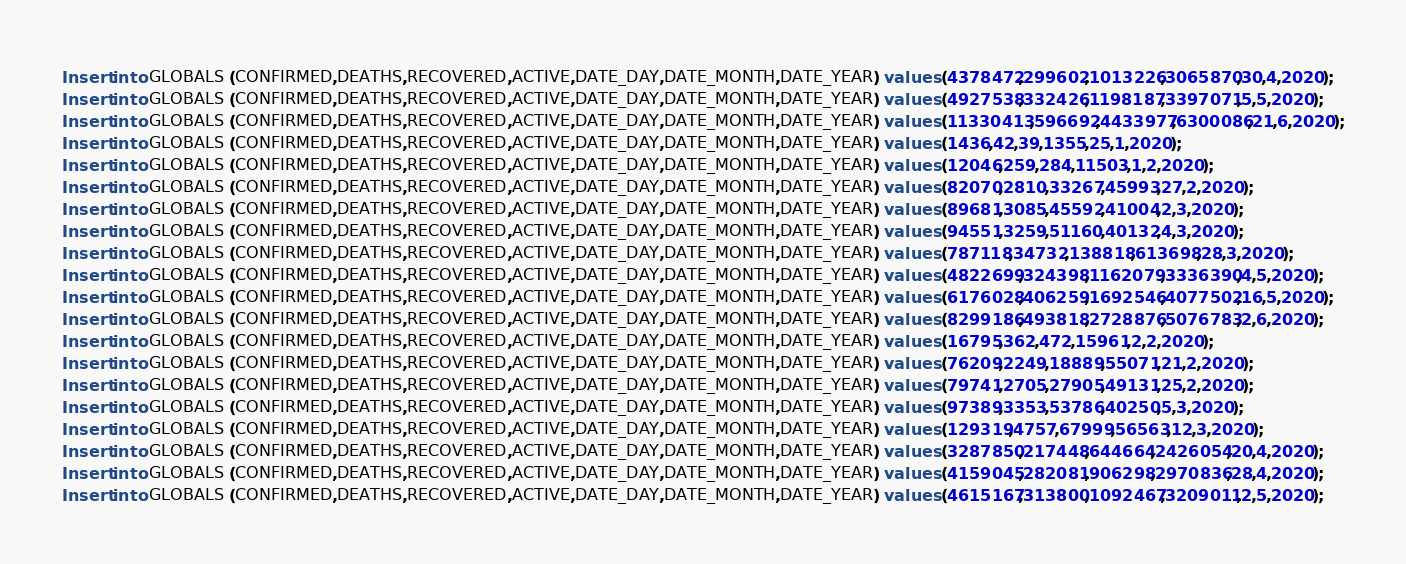Convert code to text. <code><loc_0><loc_0><loc_500><loc_500><_SQL_>Insert into GLOBALS (CONFIRMED,DEATHS,RECOVERED,ACTIVE,DATE_DAY,DATE_MONTH,DATE_YEAR) values (4378472,299602,1013226,3065870,30,4,2020);
Insert into GLOBALS (CONFIRMED,DEATHS,RECOVERED,ACTIVE,DATE_DAY,DATE_MONTH,DATE_YEAR) values (4927538,332426,1198187,3397071,5,5,2020);
Insert into GLOBALS (CONFIRMED,DEATHS,RECOVERED,ACTIVE,DATE_DAY,DATE_MONTH,DATE_YEAR) values (11330413,596692,4433977,6300086,21,6,2020);
Insert into GLOBALS (CONFIRMED,DEATHS,RECOVERED,ACTIVE,DATE_DAY,DATE_MONTH,DATE_YEAR) values (1436,42,39,1355,25,1,2020);
Insert into GLOBALS (CONFIRMED,DEATHS,RECOVERED,ACTIVE,DATE_DAY,DATE_MONTH,DATE_YEAR) values (12046,259,284,11503,1,2,2020);
Insert into GLOBALS (CONFIRMED,DEATHS,RECOVERED,ACTIVE,DATE_DAY,DATE_MONTH,DATE_YEAR) values (82070,2810,33267,45993,27,2,2020);
Insert into GLOBALS (CONFIRMED,DEATHS,RECOVERED,ACTIVE,DATE_DAY,DATE_MONTH,DATE_YEAR) values (89681,3085,45592,41004,2,3,2020);
Insert into GLOBALS (CONFIRMED,DEATHS,RECOVERED,ACTIVE,DATE_DAY,DATE_MONTH,DATE_YEAR) values (94551,3259,51160,40132,4,3,2020);
Insert into GLOBALS (CONFIRMED,DEATHS,RECOVERED,ACTIVE,DATE_DAY,DATE_MONTH,DATE_YEAR) values (787118,34732,138818,613698,28,3,2020);
Insert into GLOBALS (CONFIRMED,DEATHS,RECOVERED,ACTIVE,DATE_DAY,DATE_MONTH,DATE_YEAR) values (4822699,324398,1162079,3336390,4,5,2020);
Insert into GLOBALS (CONFIRMED,DEATHS,RECOVERED,ACTIVE,DATE_DAY,DATE_MONTH,DATE_YEAR) values (6176028,406259,1692546,4077502,16,5,2020);
Insert into GLOBALS (CONFIRMED,DEATHS,RECOVERED,ACTIVE,DATE_DAY,DATE_MONTH,DATE_YEAR) values (8299186,493818,2728876,5076783,2,6,2020);
Insert into GLOBALS (CONFIRMED,DEATHS,RECOVERED,ACTIVE,DATE_DAY,DATE_MONTH,DATE_YEAR) values (16795,362,472,15961,2,2,2020);
Insert into GLOBALS (CONFIRMED,DEATHS,RECOVERED,ACTIVE,DATE_DAY,DATE_MONTH,DATE_YEAR) values (76209,2249,18889,55071,21,2,2020);
Insert into GLOBALS (CONFIRMED,DEATHS,RECOVERED,ACTIVE,DATE_DAY,DATE_MONTH,DATE_YEAR) values (79741,2705,27905,49131,25,2,2020);
Insert into GLOBALS (CONFIRMED,DEATHS,RECOVERED,ACTIVE,DATE_DAY,DATE_MONTH,DATE_YEAR) values (97389,3353,53786,40250,5,3,2020);
Insert into GLOBALS (CONFIRMED,DEATHS,RECOVERED,ACTIVE,DATE_DAY,DATE_MONTH,DATE_YEAR) values (129319,4757,67999,56563,12,3,2020);
Insert into GLOBALS (CONFIRMED,DEATHS,RECOVERED,ACTIVE,DATE_DAY,DATE_MONTH,DATE_YEAR) values (3287850,217448,644664,2426054,20,4,2020);
Insert into GLOBALS (CONFIRMED,DEATHS,RECOVERED,ACTIVE,DATE_DAY,DATE_MONTH,DATE_YEAR) values (4159045,282081,906298,2970836,28,4,2020);
Insert into GLOBALS (CONFIRMED,DEATHS,RECOVERED,ACTIVE,DATE_DAY,DATE_MONTH,DATE_YEAR) values (4615167,313800,1092467,3209011,2,5,2020);</code> 